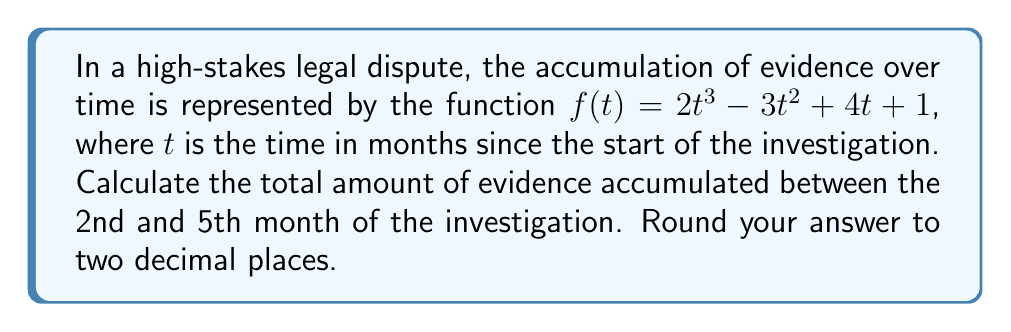Could you help me with this problem? To solve this problem, we need to calculate the area under the curve $f(t)$ between $t=2$ and $t=5$. This can be done using definite integration.

1) The integral we need to evaluate is:

   $$\int_2^5 (2t^3 - 3t^2 + 4t + 1) dt$$

2) Let's integrate each term:
   
   $$\int 2t^3 dt = \frac{1}{2}t^4$$
   $$\int -3t^2 dt = -t^3$$
   $$\int 4t dt = 2t^2$$
   $$\int 1 dt = t$$

3) Putting it all together:

   $$\int (2t^3 - 3t^2 + 4t + 1) dt = \frac{1}{2}t^4 - t^3 + 2t^2 + t + C$$

4) Now, we apply the limits:

   $$[\frac{1}{2}t^4 - t^3 + 2t^2 + t]_2^5$$

5) Evaluate at $t=5$:
   
   $$\frac{1}{2}(5^4) - 5^3 + 2(5^2) + 5 = 312.5 - 125 + 50 + 5 = 242.5$$

6) Evaluate at $t=2$:

   $$\frac{1}{2}(2^4) - 2^3 + 2(2^2) + 2 = 8 - 8 + 8 + 2 = 10$$

7) Subtract:

   $$242.5 - 10 = 232.5$$

Therefore, the total amount of evidence accumulated between the 2nd and 5th month is 232.5 units.
Answer: 232.50 units of evidence 